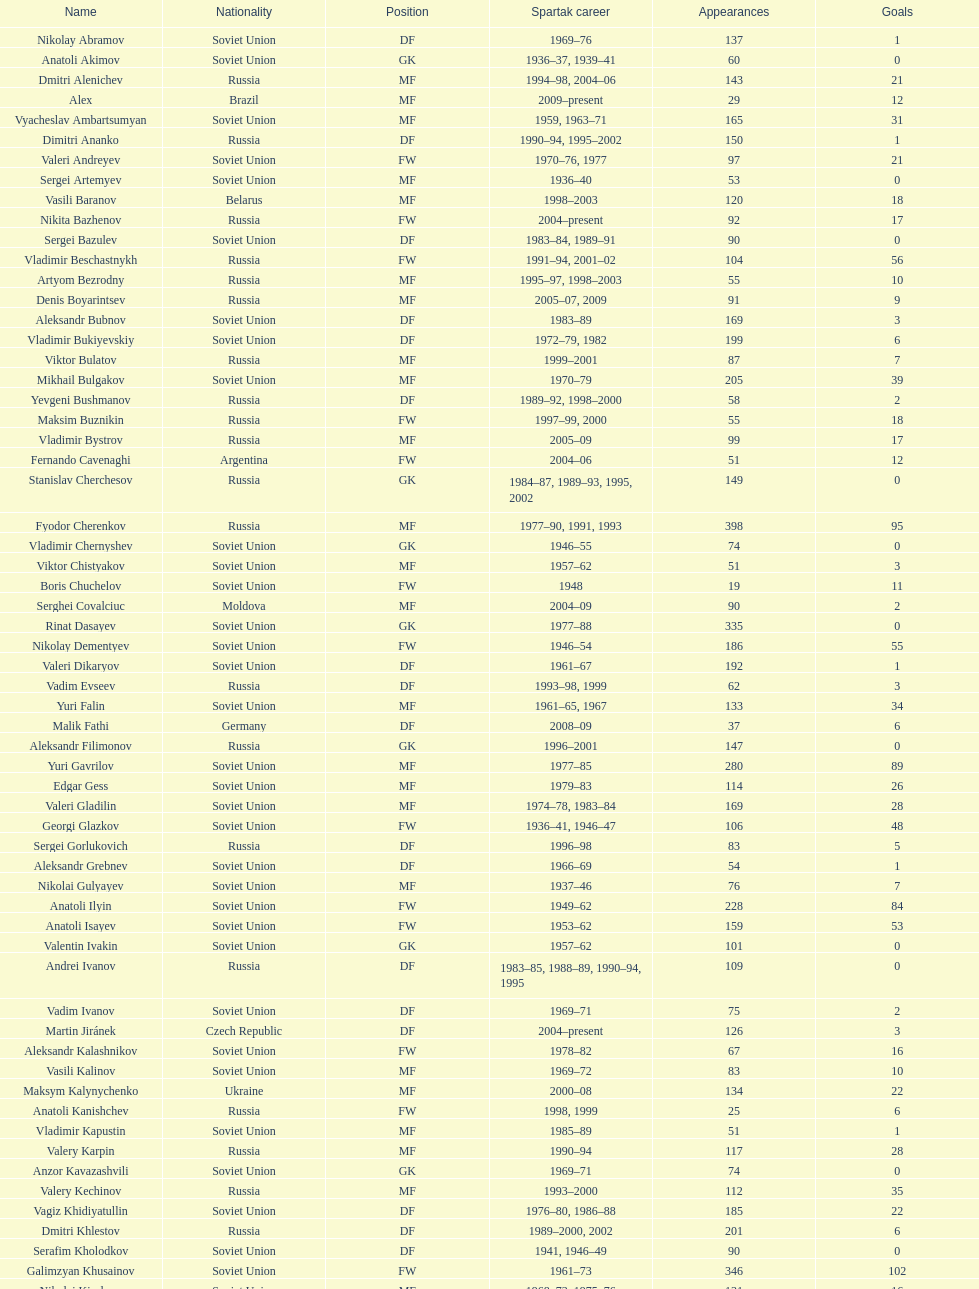Who has the most goals among the players? Nikita Simonyan. 